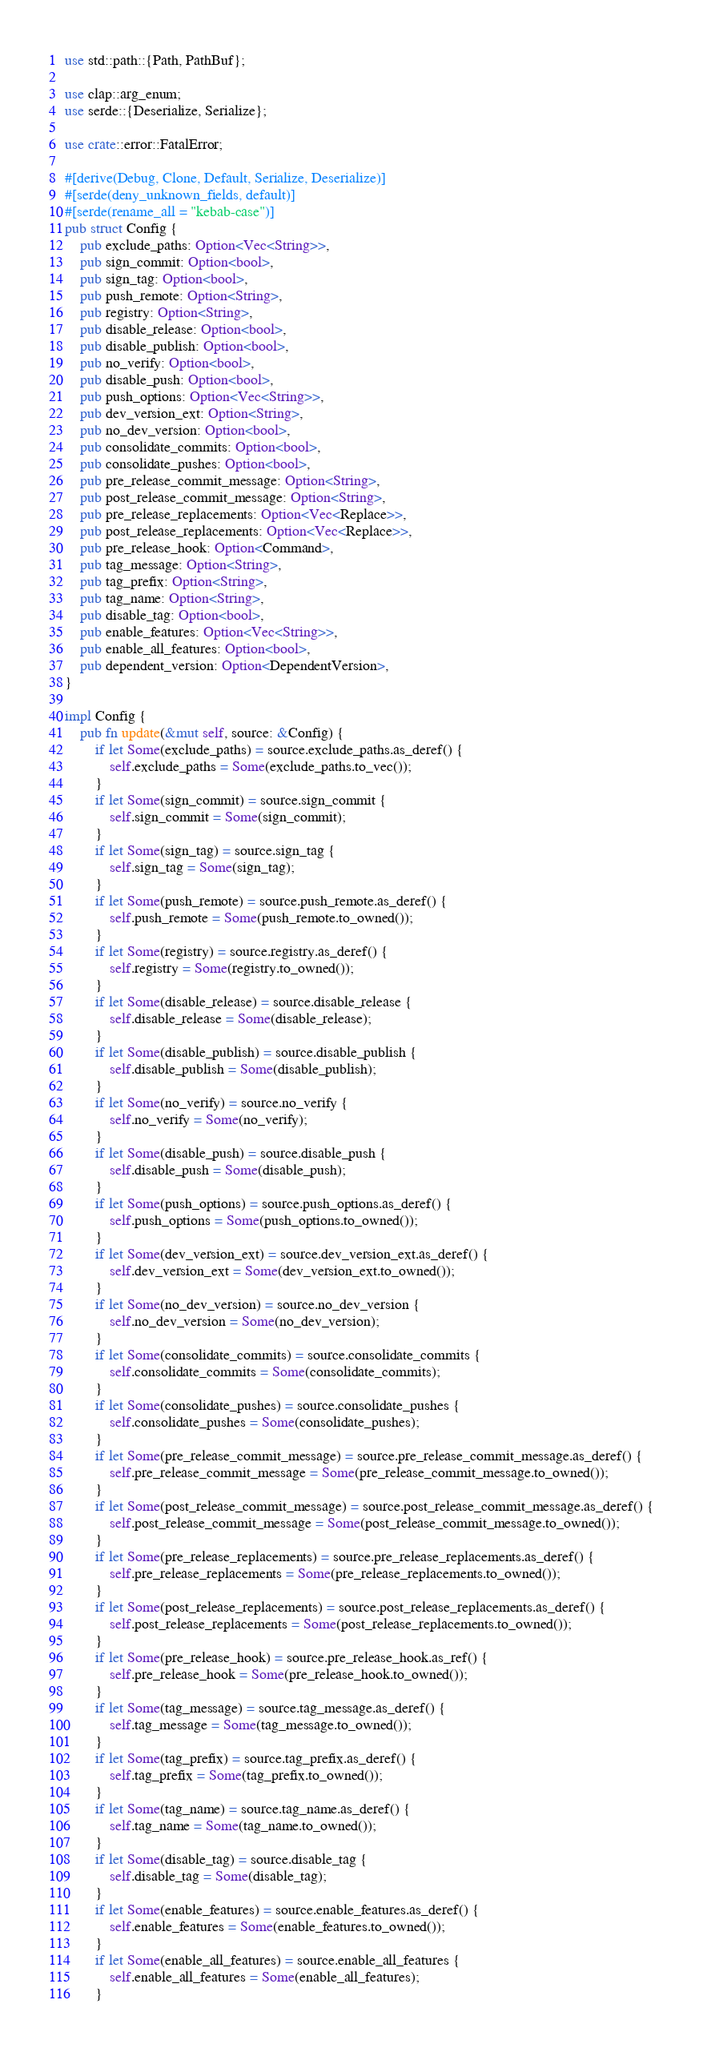Convert code to text. <code><loc_0><loc_0><loc_500><loc_500><_Rust_>use std::path::{Path, PathBuf};

use clap::arg_enum;
use serde::{Deserialize, Serialize};

use crate::error::FatalError;

#[derive(Debug, Clone, Default, Serialize, Deserialize)]
#[serde(deny_unknown_fields, default)]
#[serde(rename_all = "kebab-case")]
pub struct Config {
    pub exclude_paths: Option<Vec<String>>,
    pub sign_commit: Option<bool>,
    pub sign_tag: Option<bool>,
    pub push_remote: Option<String>,
    pub registry: Option<String>,
    pub disable_release: Option<bool>,
    pub disable_publish: Option<bool>,
    pub no_verify: Option<bool>,
    pub disable_push: Option<bool>,
    pub push_options: Option<Vec<String>>,
    pub dev_version_ext: Option<String>,
    pub no_dev_version: Option<bool>,
    pub consolidate_commits: Option<bool>,
    pub consolidate_pushes: Option<bool>,
    pub pre_release_commit_message: Option<String>,
    pub post_release_commit_message: Option<String>,
    pub pre_release_replacements: Option<Vec<Replace>>,
    pub post_release_replacements: Option<Vec<Replace>>,
    pub pre_release_hook: Option<Command>,
    pub tag_message: Option<String>,
    pub tag_prefix: Option<String>,
    pub tag_name: Option<String>,
    pub disable_tag: Option<bool>,
    pub enable_features: Option<Vec<String>>,
    pub enable_all_features: Option<bool>,
    pub dependent_version: Option<DependentVersion>,
}

impl Config {
    pub fn update(&mut self, source: &Config) {
        if let Some(exclude_paths) = source.exclude_paths.as_deref() {
            self.exclude_paths = Some(exclude_paths.to_vec());
        }
        if let Some(sign_commit) = source.sign_commit {
            self.sign_commit = Some(sign_commit);
        }
        if let Some(sign_tag) = source.sign_tag {
            self.sign_tag = Some(sign_tag);
        }
        if let Some(push_remote) = source.push_remote.as_deref() {
            self.push_remote = Some(push_remote.to_owned());
        }
        if let Some(registry) = source.registry.as_deref() {
            self.registry = Some(registry.to_owned());
        }
        if let Some(disable_release) = source.disable_release {
            self.disable_release = Some(disable_release);
        }
        if let Some(disable_publish) = source.disable_publish {
            self.disable_publish = Some(disable_publish);
        }
        if let Some(no_verify) = source.no_verify {
            self.no_verify = Some(no_verify);
        }
        if let Some(disable_push) = source.disable_push {
            self.disable_push = Some(disable_push);
        }
        if let Some(push_options) = source.push_options.as_deref() {
            self.push_options = Some(push_options.to_owned());
        }
        if let Some(dev_version_ext) = source.dev_version_ext.as_deref() {
            self.dev_version_ext = Some(dev_version_ext.to_owned());
        }
        if let Some(no_dev_version) = source.no_dev_version {
            self.no_dev_version = Some(no_dev_version);
        }
        if let Some(consolidate_commits) = source.consolidate_commits {
            self.consolidate_commits = Some(consolidate_commits);
        }
        if let Some(consolidate_pushes) = source.consolidate_pushes {
            self.consolidate_pushes = Some(consolidate_pushes);
        }
        if let Some(pre_release_commit_message) = source.pre_release_commit_message.as_deref() {
            self.pre_release_commit_message = Some(pre_release_commit_message.to_owned());
        }
        if let Some(post_release_commit_message) = source.post_release_commit_message.as_deref() {
            self.post_release_commit_message = Some(post_release_commit_message.to_owned());
        }
        if let Some(pre_release_replacements) = source.pre_release_replacements.as_deref() {
            self.pre_release_replacements = Some(pre_release_replacements.to_owned());
        }
        if let Some(post_release_replacements) = source.post_release_replacements.as_deref() {
            self.post_release_replacements = Some(post_release_replacements.to_owned());
        }
        if let Some(pre_release_hook) = source.pre_release_hook.as_ref() {
            self.pre_release_hook = Some(pre_release_hook.to_owned());
        }
        if let Some(tag_message) = source.tag_message.as_deref() {
            self.tag_message = Some(tag_message.to_owned());
        }
        if let Some(tag_prefix) = source.tag_prefix.as_deref() {
            self.tag_prefix = Some(tag_prefix.to_owned());
        }
        if let Some(tag_name) = source.tag_name.as_deref() {
            self.tag_name = Some(tag_name.to_owned());
        }
        if let Some(disable_tag) = source.disable_tag {
            self.disable_tag = Some(disable_tag);
        }
        if let Some(enable_features) = source.enable_features.as_deref() {
            self.enable_features = Some(enable_features.to_owned());
        }
        if let Some(enable_all_features) = source.enable_all_features {
            self.enable_all_features = Some(enable_all_features);
        }</code> 